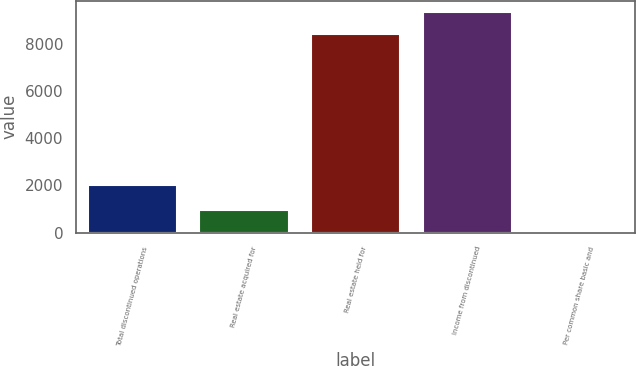Convert chart. <chart><loc_0><loc_0><loc_500><loc_500><bar_chart><fcel>Total discontinued operations<fcel>Real estate acquired for<fcel>Real estate held for<fcel>Income from discontinued<fcel>Per common share basic and<nl><fcel>2010<fcel>946<fcel>8422<fcel>9368<fcel>0.09<nl></chart> 